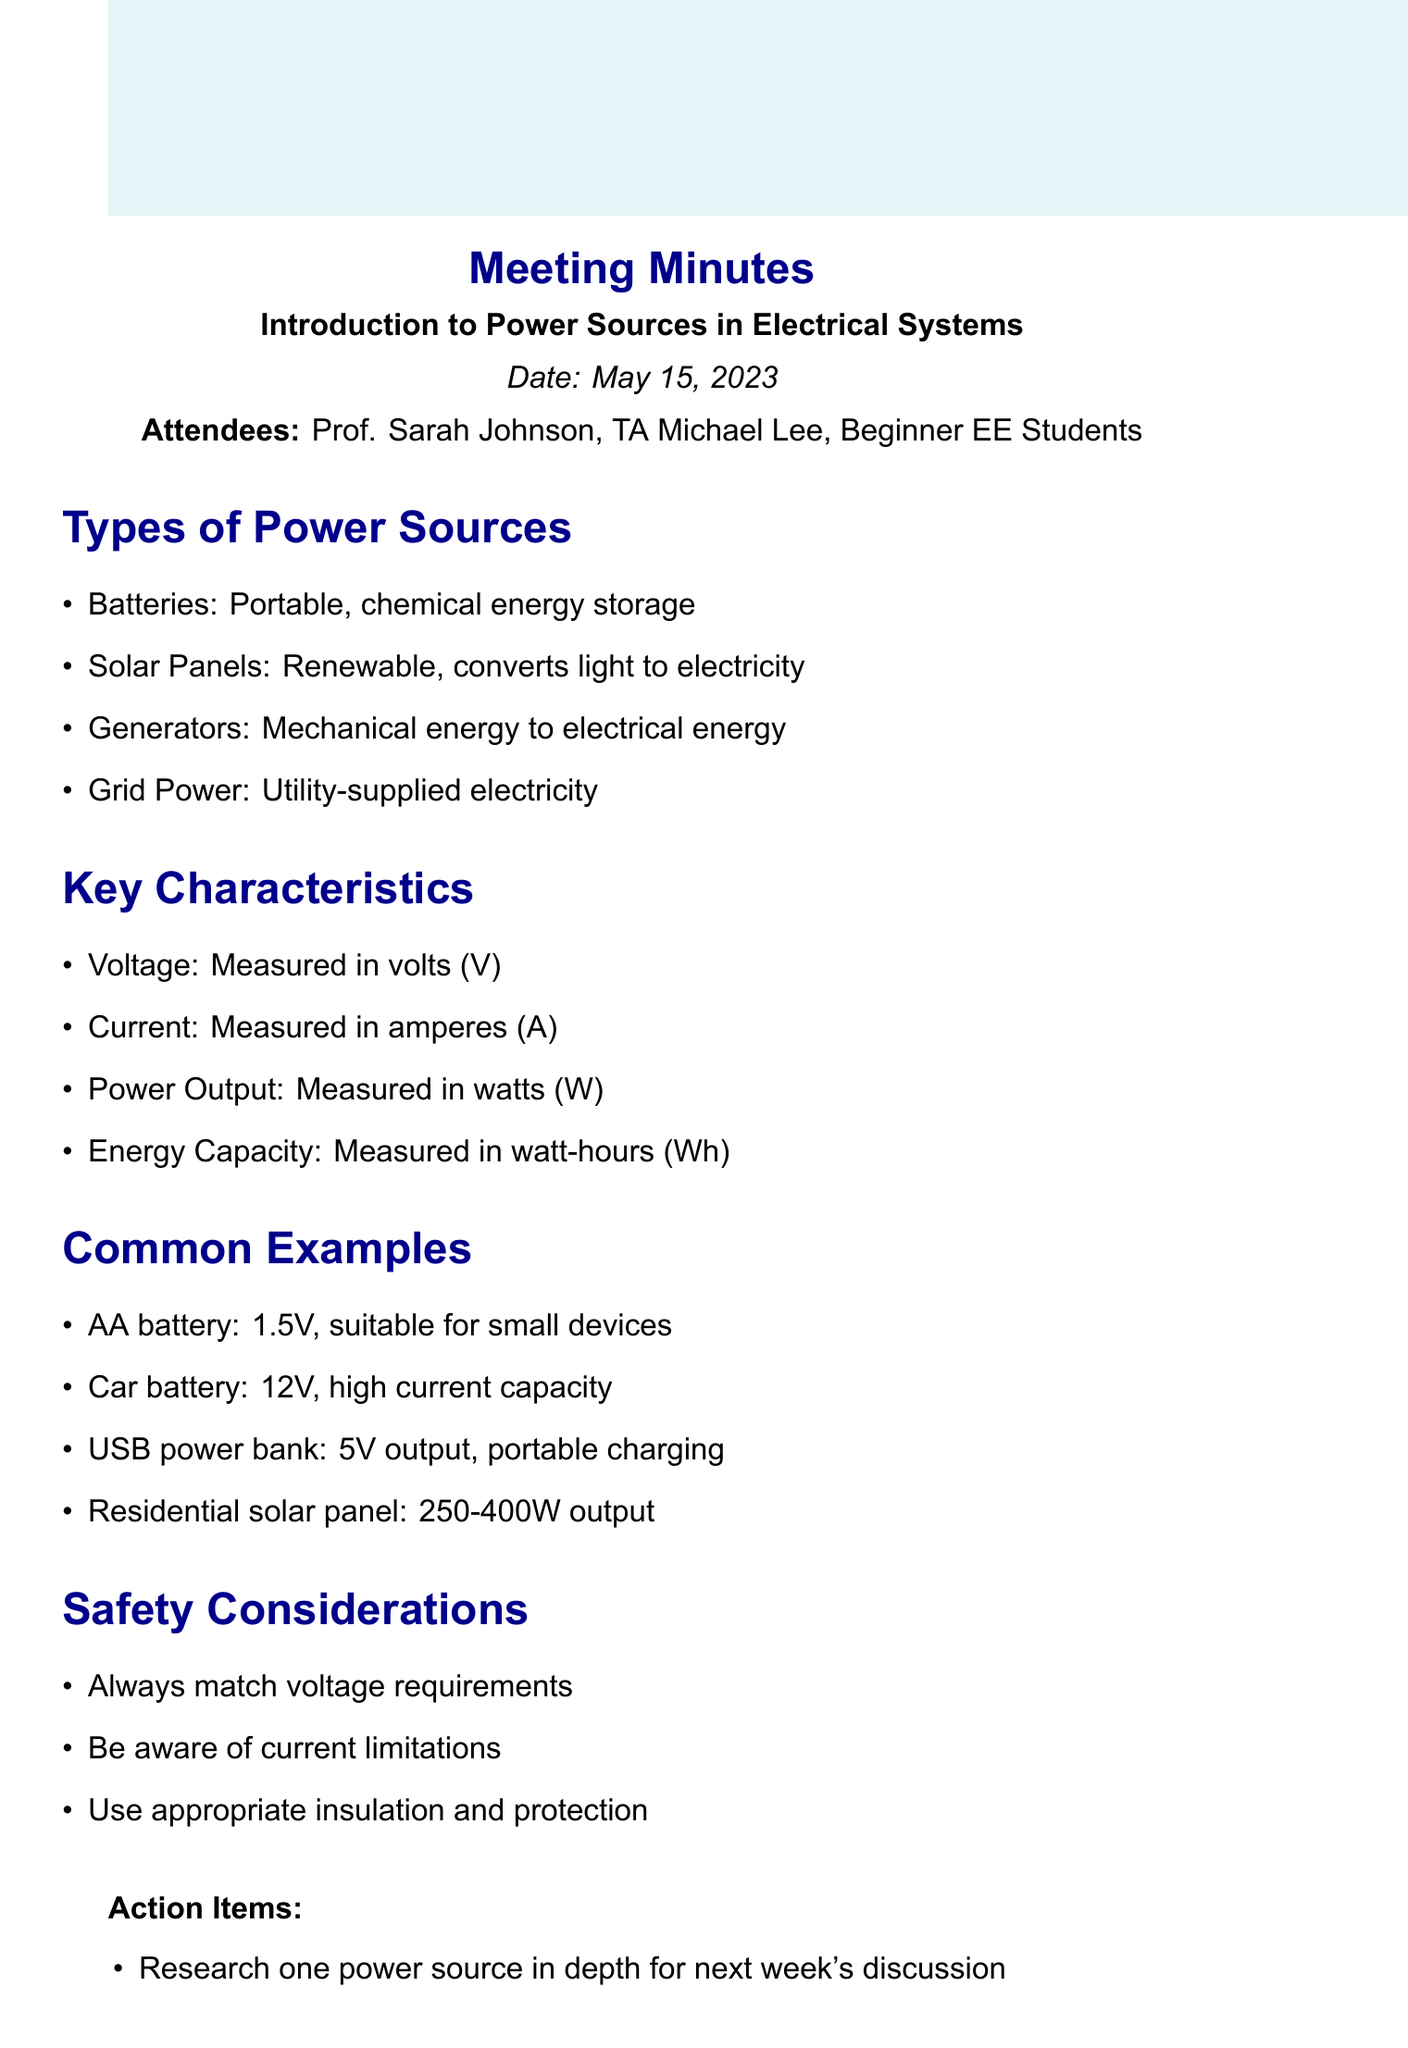what is the meeting title? The meeting title is stated at the beginning of the document to provide a clear context for the discussion.
Answer: Introduction to Power Sources in Electrical Systems who was the primary presenter in the meeting? The primary presenter is indicated by their title, often denoting authority or expertise in the subject matter discussed.
Answer: Prof. Sarah Johnson how many types of power sources are listed in the document? The document outlines specific types of power sources under one of the agenda items, providing a clear count.
Answer: 4 what is the energy capacity unit mentioned? The energy capacity is listed under key characteristics, stating its specific unit of measurement used in electrical systems.
Answer: watt-hours what is the voltage of a car battery? The specific voltage of a common power source, the car battery, is included in the examples to illustrate its characteristics.
Answer: 12V what action is suggested for next week's discussion? The action items list includes specific tasks for attendees to prepare for the next meeting, indicating what is expected.
Answer: Research one power source in depth what is the date of the next meeting? The next meeting date is specified at the conclusion of the document to inform attendees of future engagements.
Answer: May 22, 2023 what type of power source converts light to electricity? The types of power sources listed include one that specifically deals with the conversion of light energy, highlighting its renewable nature.
Answer: Solar Panels 